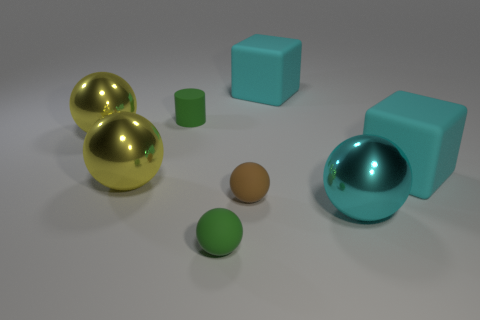How does the lighting affect the appearance of the objects in the image? The lighting provides a soft glow that highlights the objects' surfaces, creating reflections on the shiny materials and a subtle shadow effect that gives depth to the scene. 